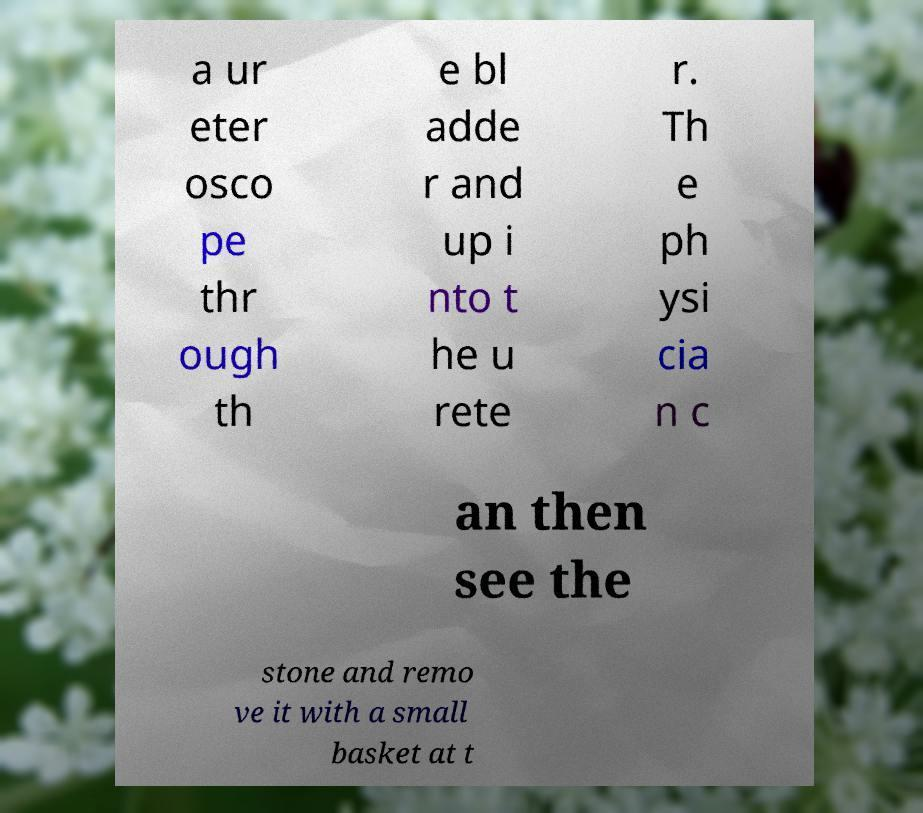Could you assist in decoding the text presented in this image and type it out clearly? a ur eter osco pe thr ough th e bl adde r and up i nto t he u rete r. Th e ph ysi cia n c an then see the stone and remo ve it with a small basket at t 